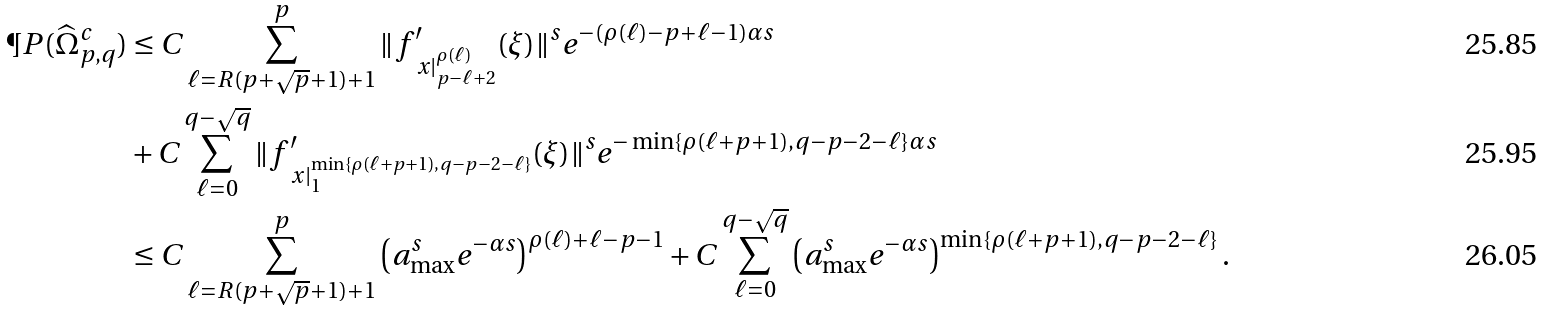<formula> <loc_0><loc_0><loc_500><loc_500>\P P ( \widehat { \Omega } _ { p , q } ^ { c } ) & \leq C \sum _ { \ell = R ( p + \sqrt { p } + 1 ) + 1 } ^ { p } \| f _ { \ x | _ { p - \ell + 2 } ^ { \rho ( \ell ) } } ^ { \prime } ( \xi ) \| ^ { s } e ^ { - ( \rho ( \ell ) - p + \ell - 1 ) \alpha s } \\ & + C \sum _ { \ell = 0 } ^ { q - \sqrt { q } } \| f _ { \ x | _ { 1 } ^ { \min \{ \rho ( \ell + p + 1 ) , q - p - 2 - \ell \} } } ^ { \prime } ( \xi ) \| ^ { s } e ^ { - \min \{ \rho ( \ell + p + 1 ) , q - p - 2 - \ell \} \alpha s } \\ & \leq C \sum _ { \ell = R ( p + \sqrt { p } + 1 ) + 1 } ^ { p } \left ( a _ { \max } ^ { s } e ^ { - \alpha s } \right ) ^ { \rho ( \ell ) + \ell - p - 1 } + C \sum _ { \ell = 0 } ^ { q - \sqrt { q } } \left ( a _ { \max } ^ { s } e ^ { - \alpha s } \right ) ^ { \min \{ \rho ( \ell + p + 1 ) , q - p - 2 - \ell \} } .</formula> 